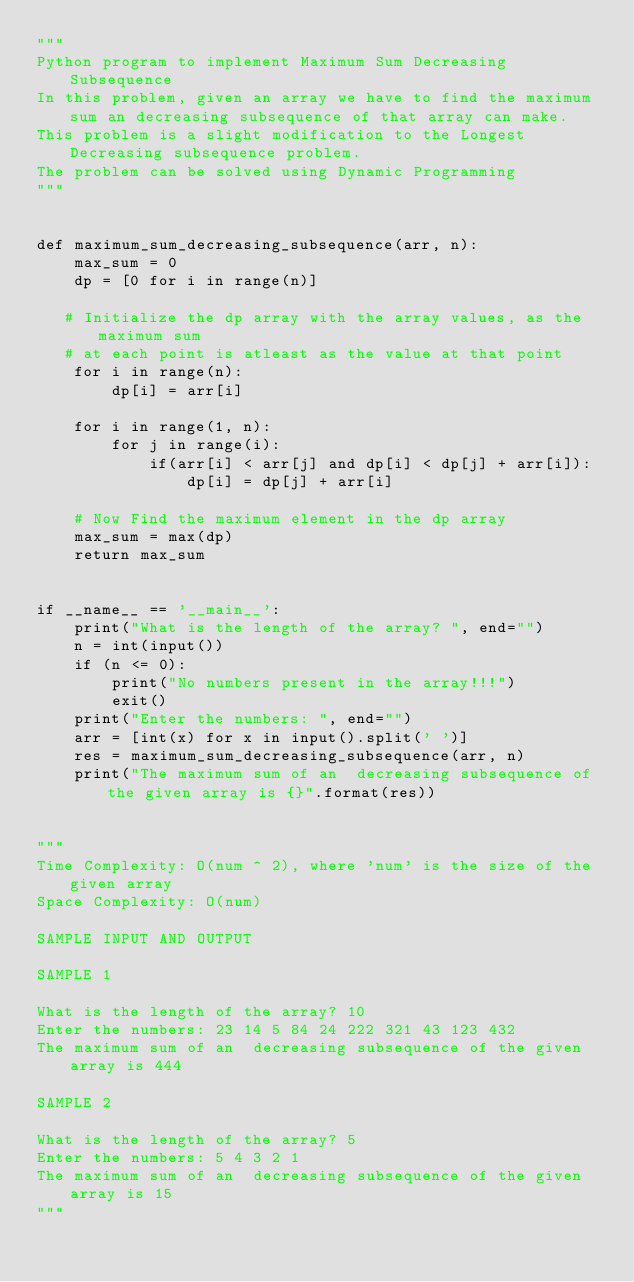<code> <loc_0><loc_0><loc_500><loc_500><_Python_>"""
Python program to implement Maximum Sum Decreasing Subsequence
In this problem, given an array we have to find the maximum sum an decreasing subsequence of that array can make.
This problem is a slight modification to the Longest Decreasing subsequence problem.
The problem can be solved using Dynamic Programming
"""


def maximum_sum_decreasing_subsequence(arr, n):
    max_sum = 0
    dp = [0 for i in range(n)]

   # Initialize the dp array with the array values, as the maximum sum
   # at each point is atleast as the value at that point
    for i in range(n):
        dp[i] = arr[i]

    for i in range(1, n):
        for j in range(i):
            if(arr[i] < arr[j] and dp[i] < dp[j] + arr[i]):
                dp[i] = dp[j] + arr[i]

    # Now Find the maximum element in the dp array
    max_sum = max(dp)
    return max_sum


if __name__ == '__main__':
    print("What is the length of the array? ", end="")
    n = int(input())
    if (n <= 0):
        print("No numbers present in the array!!!")
        exit()
    print("Enter the numbers: ", end="")
    arr = [int(x) for x in input().split(' ')]
    res = maximum_sum_decreasing_subsequence(arr, n)
    print("The maximum sum of an  decreasing subsequence of the given array is {}".format(res))


"""
Time Complexity: O(num ^ 2), where 'num' is the size of the given array
Space Complexity: O(num)

SAMPLE INPUT AND OUTPUT

SAMPLE 1

What is the length of the array? 10
Enter the numbers: 23 14 5 84 24 222 321 43 123 432
The maximum sum of an  decreasing subsequence of the given array is 444

SAMPLE 2

What is the length of the array? 5
Enter the numbers: 5 4 3 2 1
The maximum sum of an  decreasing subsequence of the given array is 15
"""
</code> 